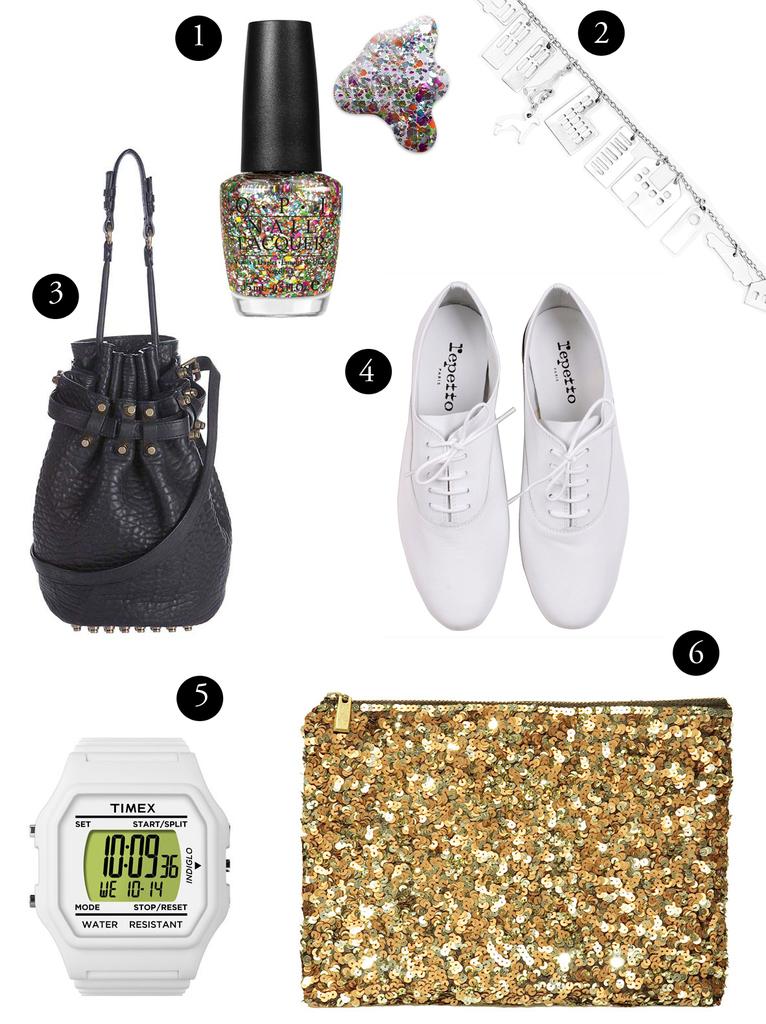What brand are the white shoes?
Your response must be concise. Repetto. What brand is the watch?
Keep it short and to the point. Timex. 